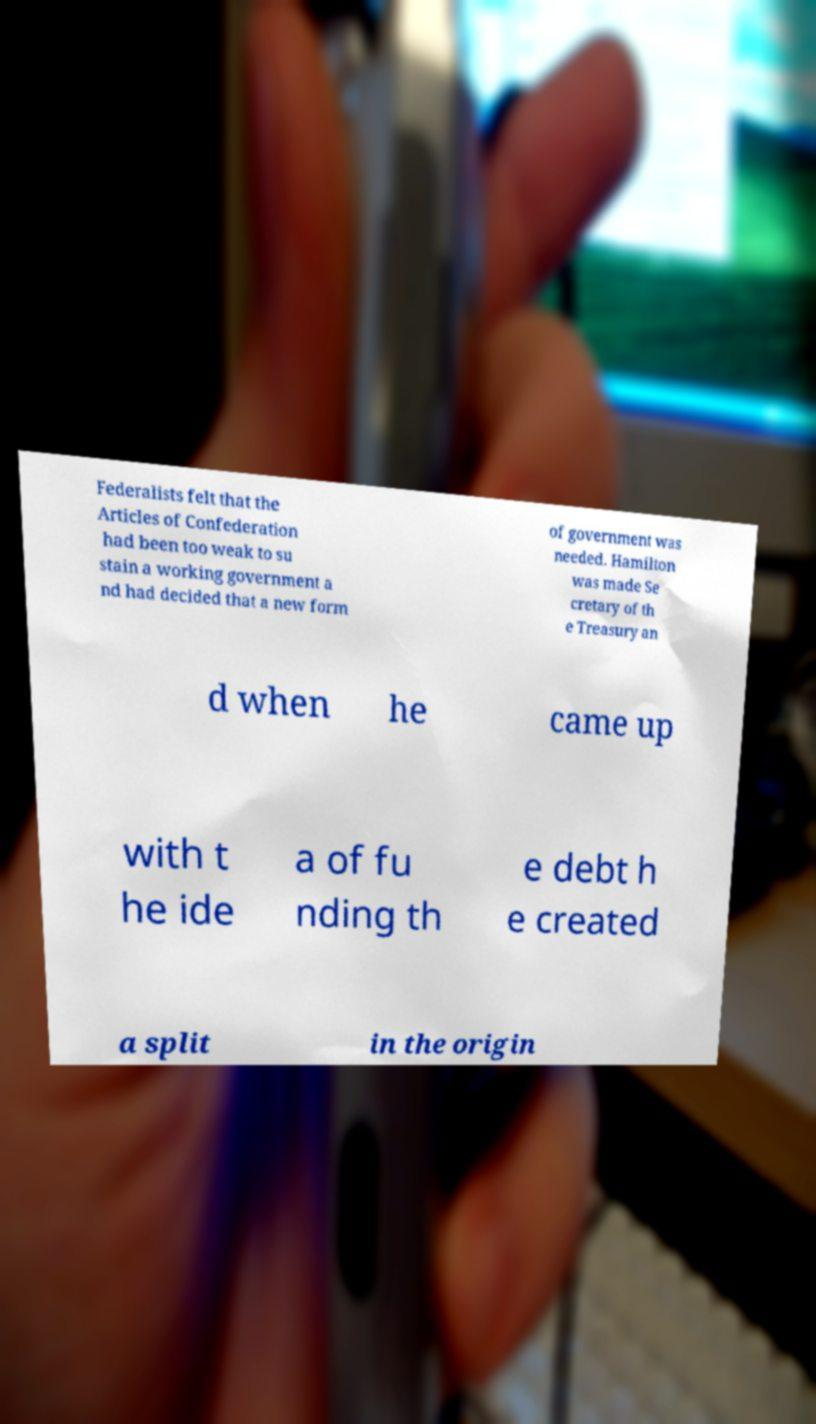For documentation purposes, I need the text within this image transcribed. Could you provide that? Federalists felt that the Articles of Confederation had been too weak to su stain a working government a nd had decided that a new form of government was needed. Hamilton was made Se cretary of th e Treasury an d when he came up with t he ide a of fu nding th e debt h e created a split in the origin 